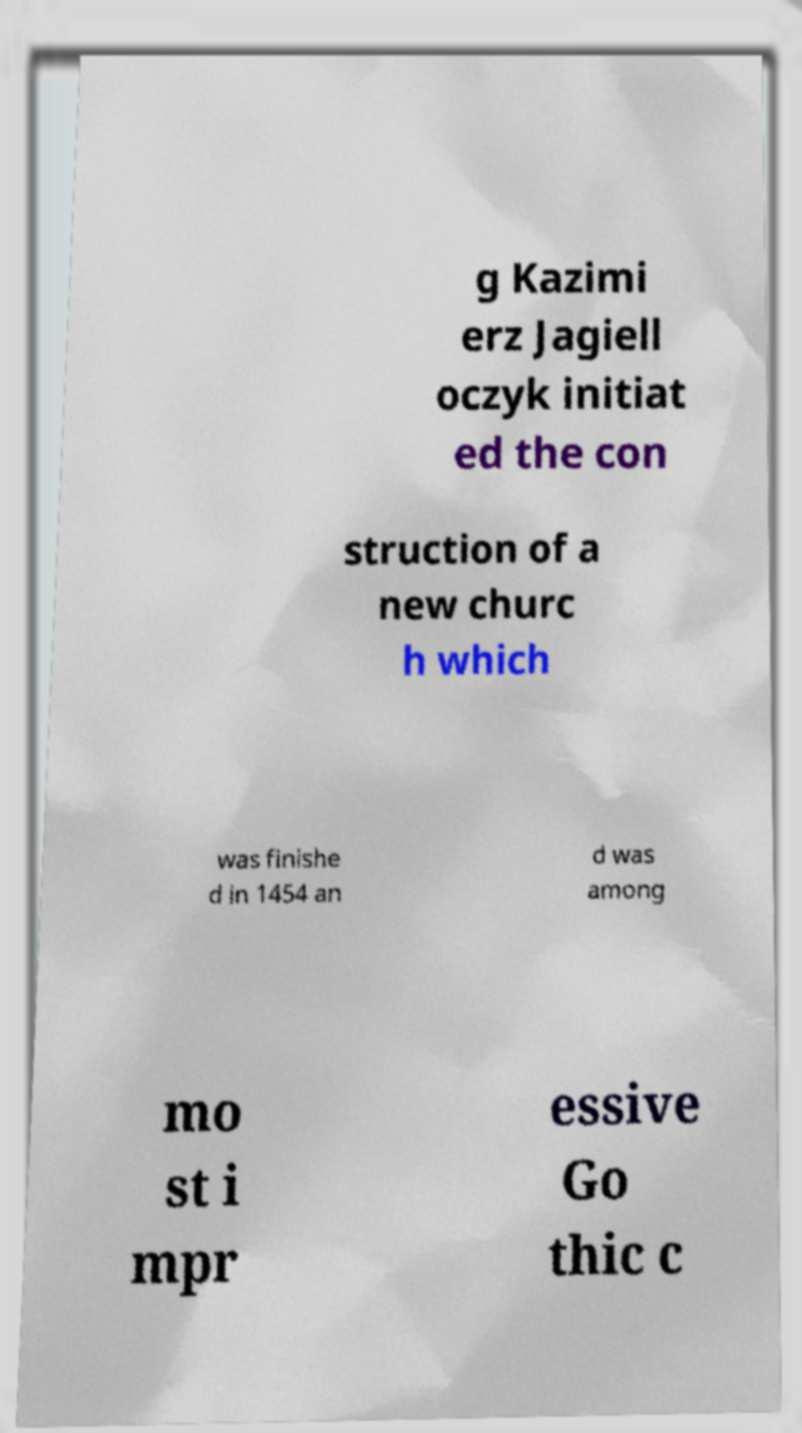Please read and relay the text visible in this image. What does it say? g Kazimi erz Jagiell oczyk initiat ed the con struction of a new churc h which was finishe d in 1454 an d was among mo st i mpr essive Go thic c 